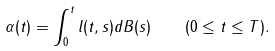Convert formula to latex. <formula><loc_0><loc_0><loc_500><loc_500>\alpha ( t ) = \int _ { 0 } ^ { t } l ( t , s ) d B ( s ) \quad ( 0 \leq t \leq T ) .</formula> 